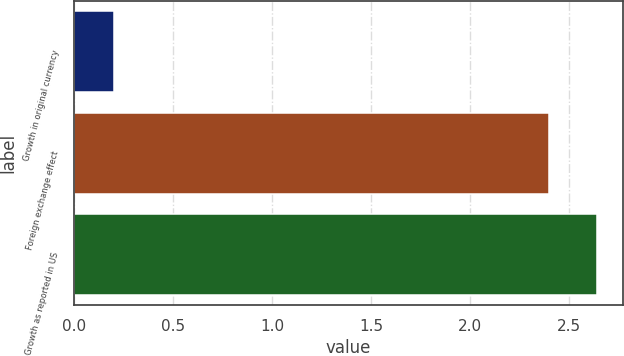Convert chart. <chart><loc_0><loc_0><loc_500><loc_500><bar_chart><fcel>Growth in original currency<fcel>Foreign exchange effect<fcel>Growth as reported in US<nl><fcel>0.2<fcel>2.4<fcel>2.64<nl></chart> 